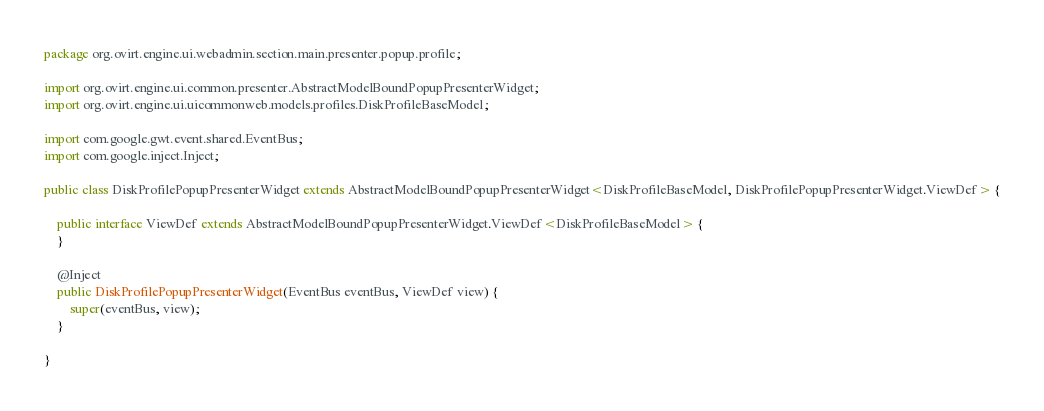Convert code to text. <code><loc_0><loc_0><loc_500><loc_500><_Java_>package org.ovirt.engine.ui.webadmin.section.main.presenter.popup.profile;

import org.ovirt.engine.ui.common.presenter.AbstractModelBoundPopupPresenterWidget;
import org.ovirt.engine.ui.uicommonweb.models.profiles.DiskProfileBaseModel;

import com.google.gwt.event.shared.EventBus;
import com.google.inject.Inject;

public class DiskProfilePopupPresenterWidget extends AbstractModelBoundPopupPresenterWidget<DiskProfileBaseModel, DiskProfilePopupPresenterWidget.ViewDef> {

    public interface ViewDef extends AbstractModelBoundPopupPresenterWidget.ViewDef<DiskProfileBaseModel> {
    }

    @Inject
    public DiskProfilePopupPresenterWidget(EventBus eventBus, ViewDef view) {
        super(eventBus, view);
    }

}
</code> 